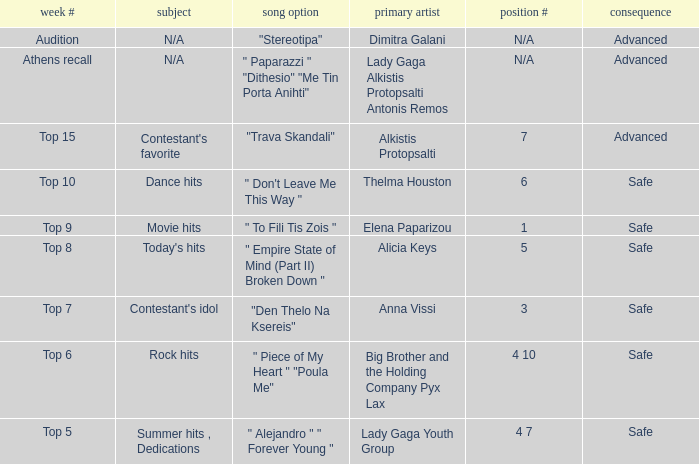Which artists have order # 1? Elena Paparizou. 